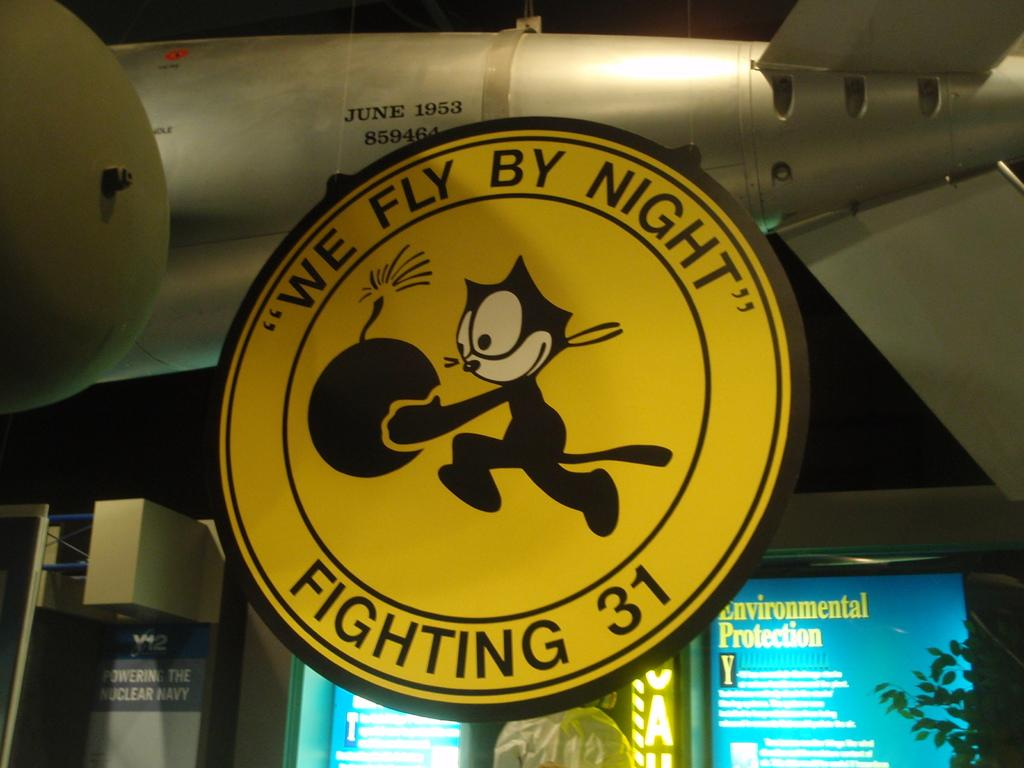<image>
Summarize the visual content of the image. A yellow sign that says We Fly By Night, Fighting 31, with a cat holding a bomb in the middle. 